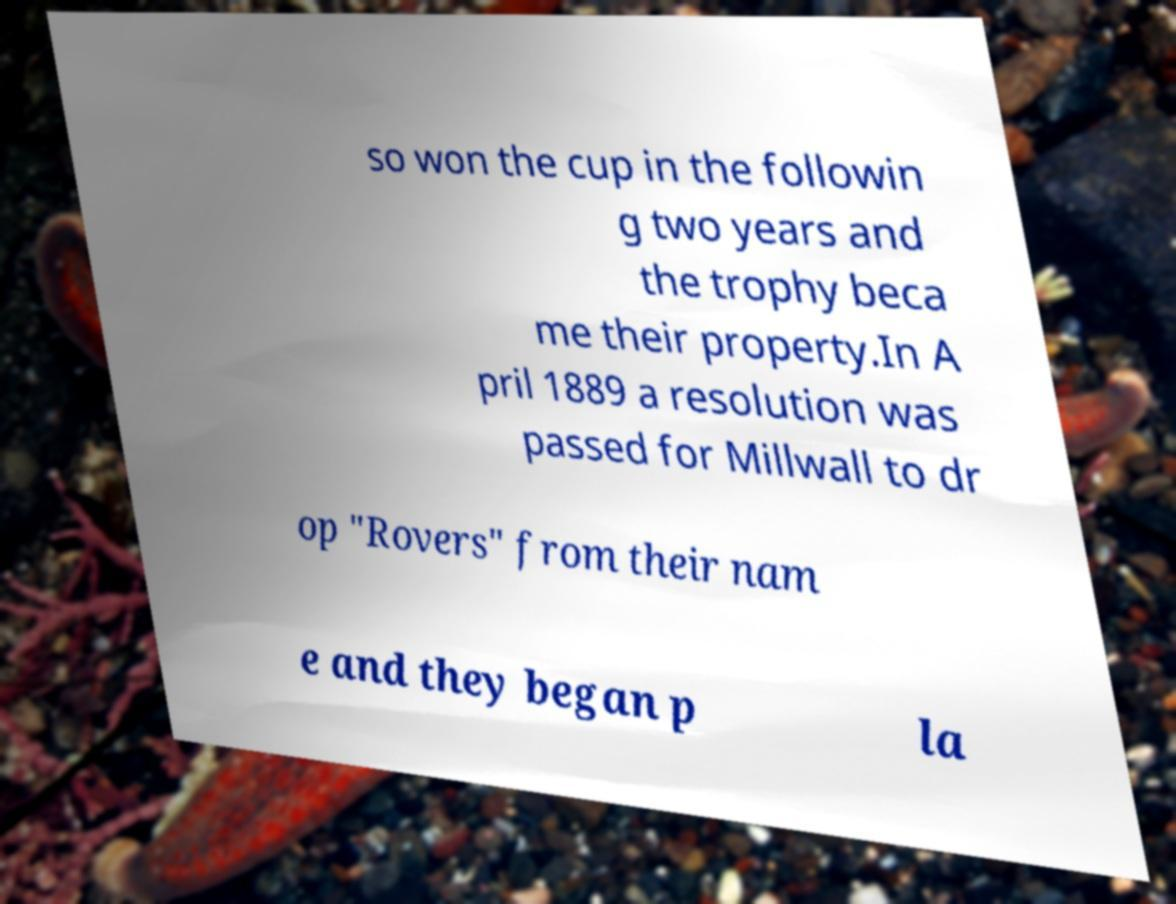Could you extract and type out the text from this image? so won the cup in the followin g two years and the trophy beca me their property.In A pril 1889 a resolution was passed for Millwall to dr op "Rovers" from their nam e and they began p la 